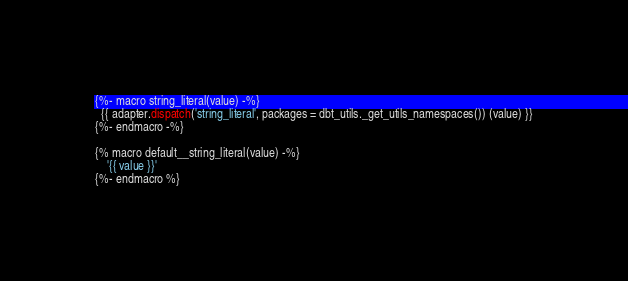<code> <loc_0><loc_0><loc_500><loc_500><_SQL_>
{%- macro string_literal(value) -%}
  {{ adapter.dispatch('string_literal', packages = dbt_utils._get_utils_namespaces()) (value) }}
{%- endmacro -%}

{% macro default__string_literal(value) -%}
    '{{ value }}'
{%- endmacro %}
</code> 